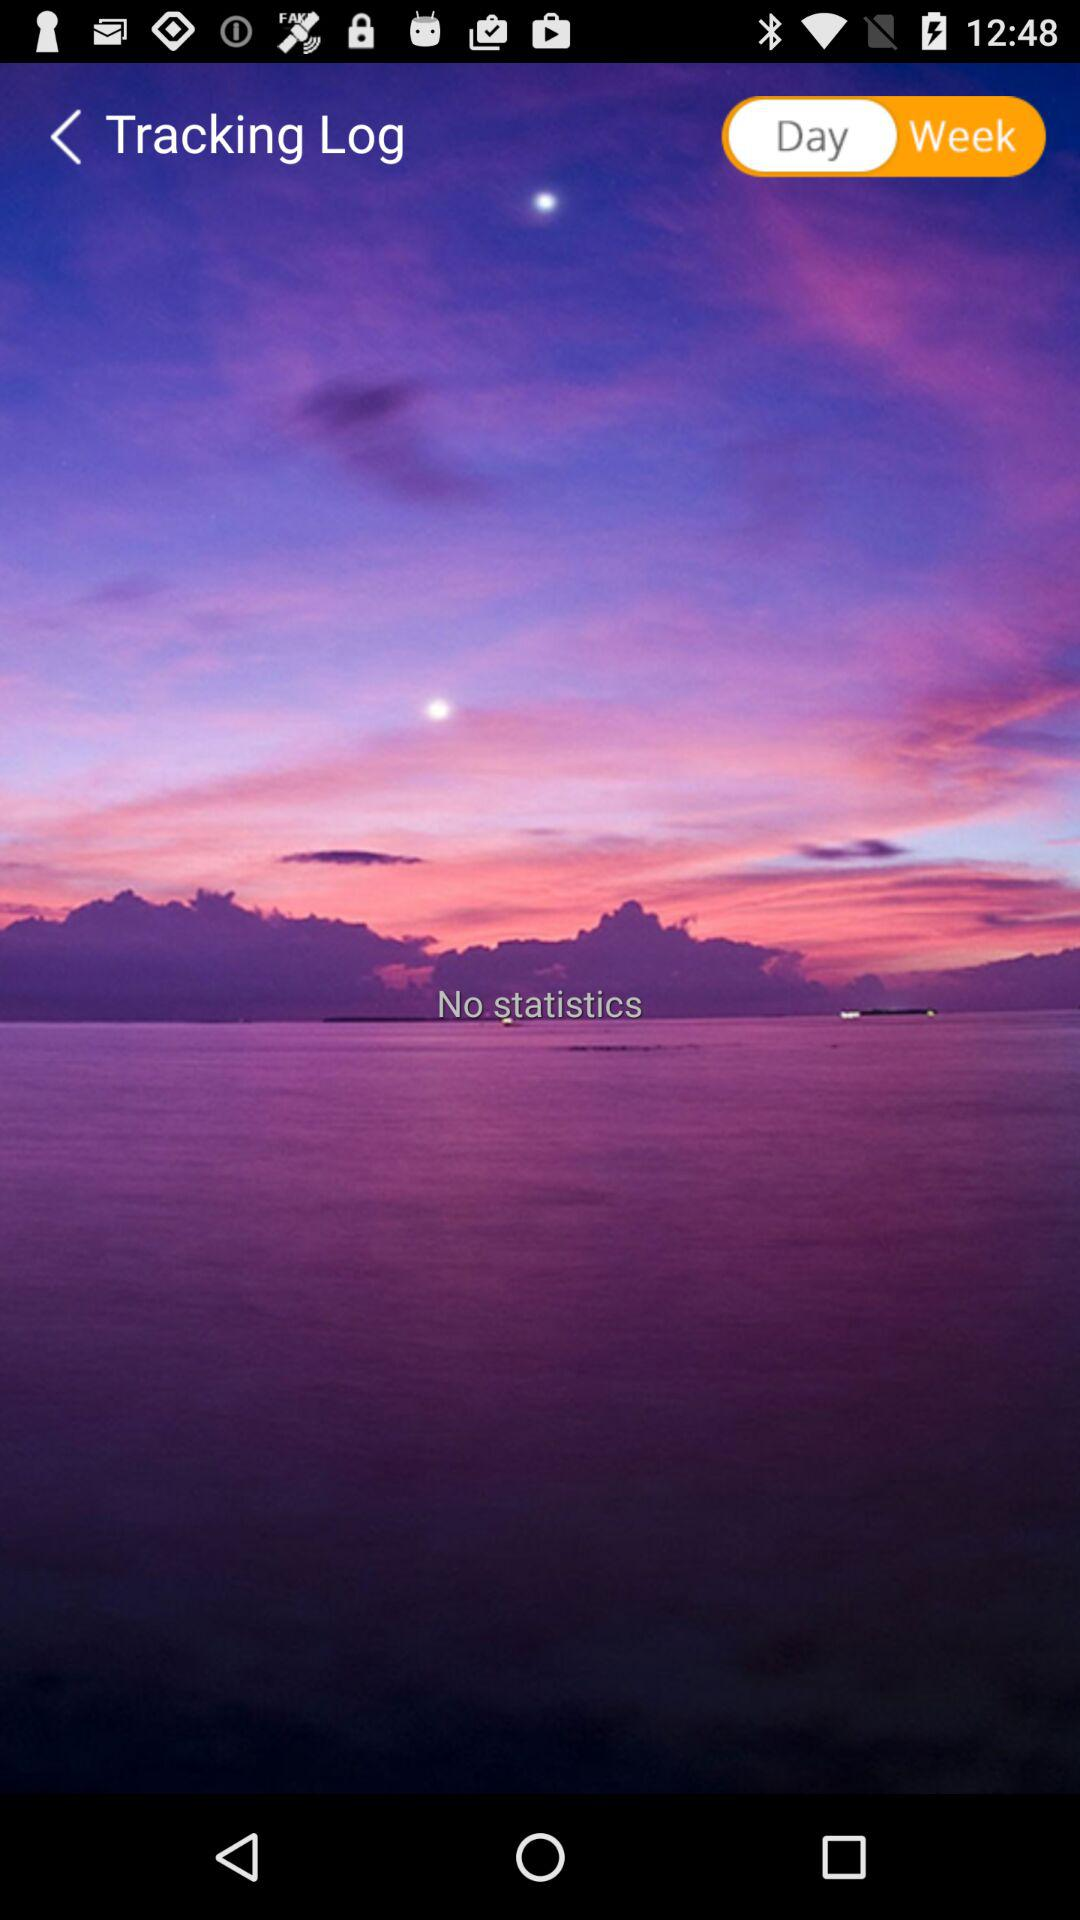On what basis is the tracking log maintained? The tracking log is maintained on the basis of days and weeks. 